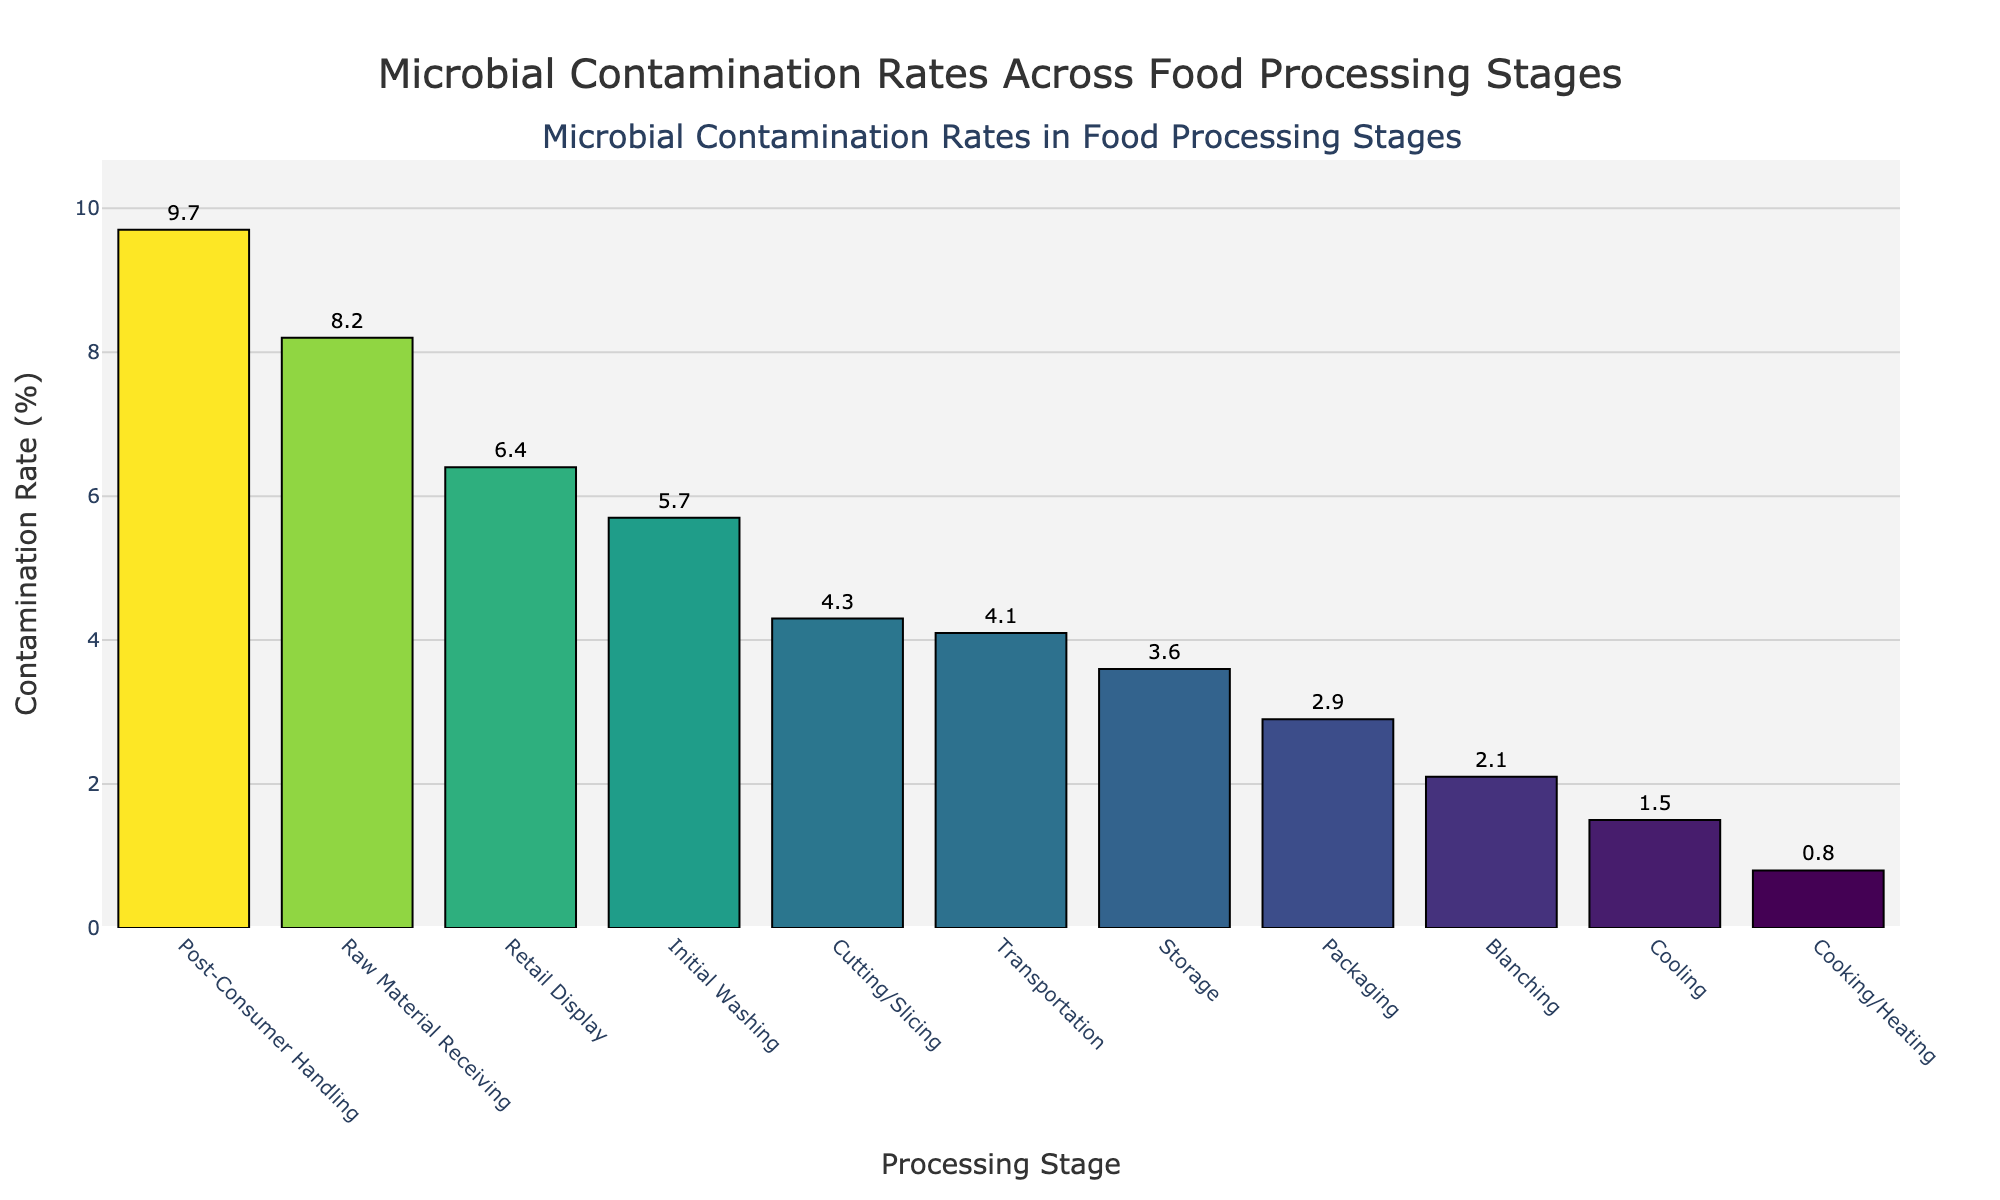What is the processing stage with the highest microbial contamination rate? First, identify the bar with the greatest height in the figure. The highest bar represents the processing stage with the highest microbial contamination rate.
Answer: Post-Consumer Handling What is the difference in microbial contamination rates between the cooking/heating stage and the retail display stage? Identify the heights of the bars corresponding to Cooking/Heating and Retail Display stages. Subtract the contamination rate of Cooking/Heating from that of Retail Display: 6.4% - 0.8% = 5.6%.
Answer: 5.6% Which processing stage has a lower microbial contamination rate: packaging or storage? Compare the heights of the bars for Packaging and Storage. The bar for Packaging is taller than the bar for Storage, indicating a higher contamination rate. Therefore, the Storage stage has a lower rate.
Answer: Storage What is the sum of the contamination rates for cooling and transportation stages? Identify the contamination rates for Cooling (1.5%) and Transportation (4.1%). Add these values: 1.5% + 4.1% = 5.6%.
Answer: 5.6% Which processing stage has almost half the contamination rate of the initial washing stage? Identify the contamination rate for Initial Washing (5.7%). Find a stage with approximately half of 5.7%, which is around 2.85%. The Packaging stage has a contamination rate closest to half (2.9%).
Answer: Packaging What is the average contamination rate across all the processing stages? Sum all the contamination rates: 8.2 + 5.7 + 4.3 + 2.1 + 0.8 + 1.5 + 2.9 + 3.6 + 4.1 + 6.4 + 9.7 = 49.3. Divide by the number of stages (11): 49.3 / 11 ≈ 4.48.
Answer: 4.48% Which stage has a contamination rate closest to the median among all stages? Rank the contamination rates in ascending order: 0.8, 1.5, 2.1, 2.9, 3.6, 4.1, 4.3, 5.7, 6.4, 8.2, 9.7. The median value is the 6th value: 4.1%. The Transportation stage has this contamination rate.
Answer: Transportation What is the visual difference between the contamination rates of raw material receiving and cooling stages? Visually compare the bars for Raw Material Receiving and Cooling. The Raw Material Receiving bar is significantly taller (8.2%) compared to the much shorter Cooling bar (1.5%).
Answer: Raw Material Receiving is much higher How many processing stages have a contamination rate greater than 5%? Identify the bars that exceed the 5% mark on the y-axis. The stages with contamination rates above 5% are Raw Material Receiving, Initial Washing, and Post-Consumer Handling. There are 3 such stages.
Answer: 3 stages 